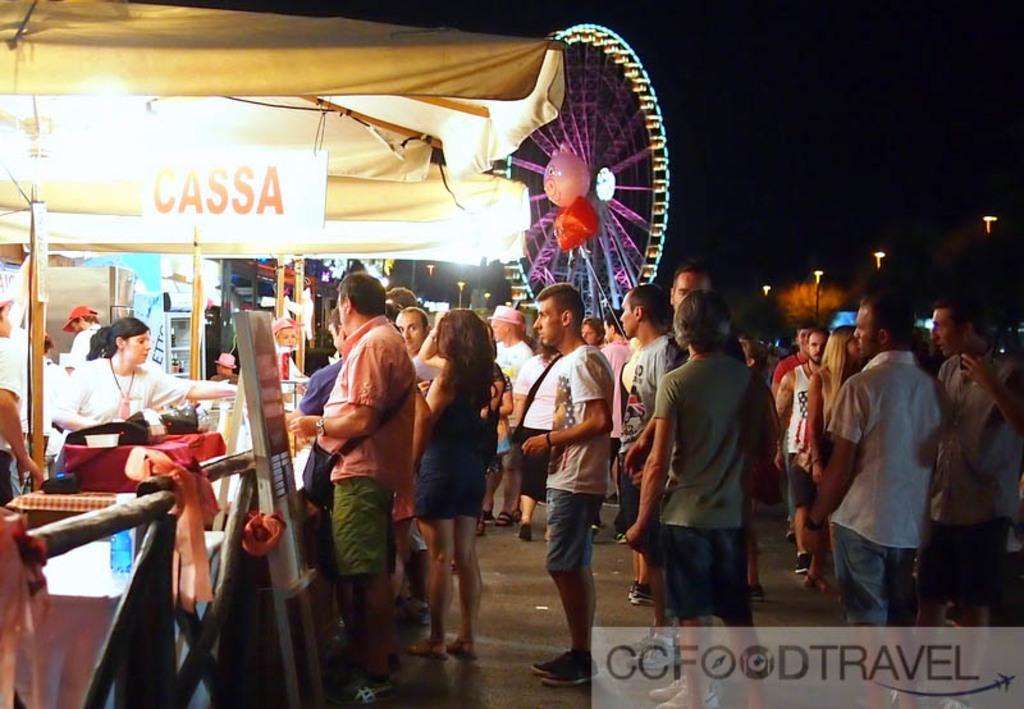Can you describe this image briefly? There is an exhibition and there is a giant wheel, beside that there are few food stalls, people were gathered around the food stalls and ordering the food. The image is captured in the night time, on the right side there are four street lights. 